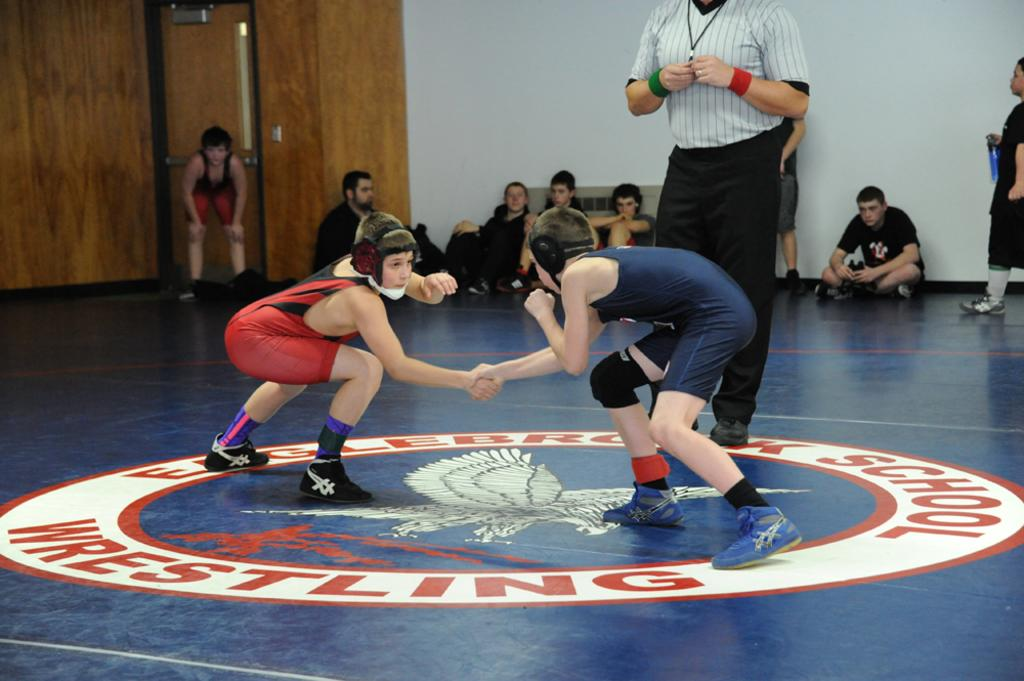<image>
Relay a brief, clear account of the picture shown. The red Englebrook Highschool Wrestling font is quite large but bold as well. 